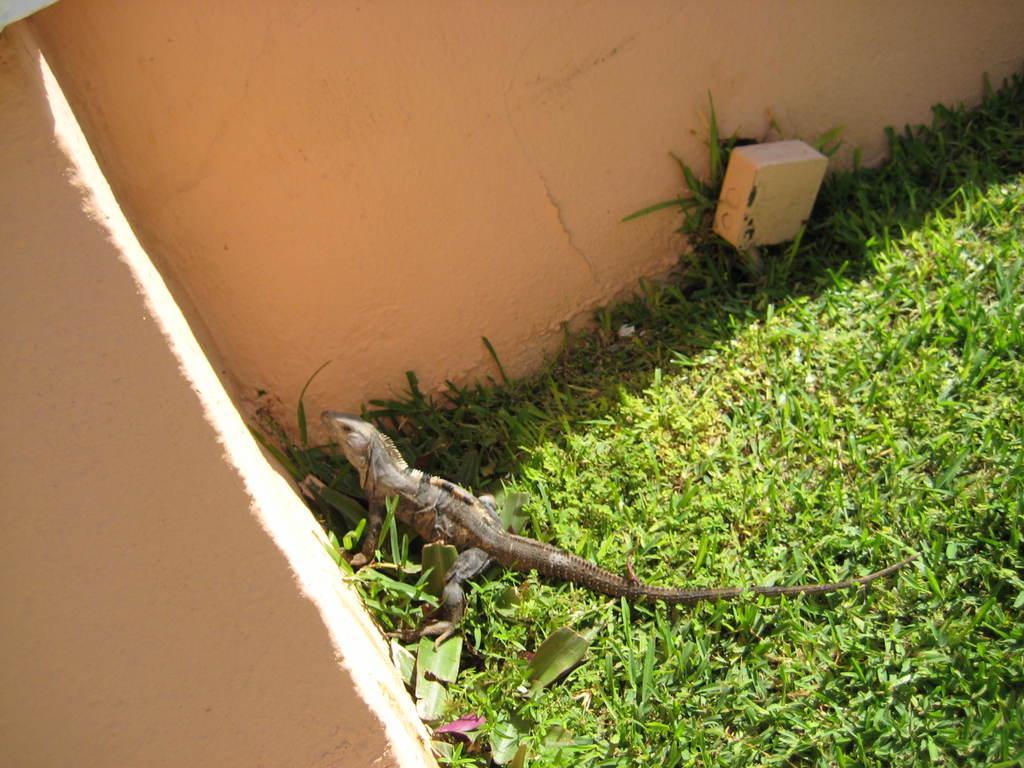Can you describe this image briefly? In this image there is grass. There is a reptile. There is a wall. 